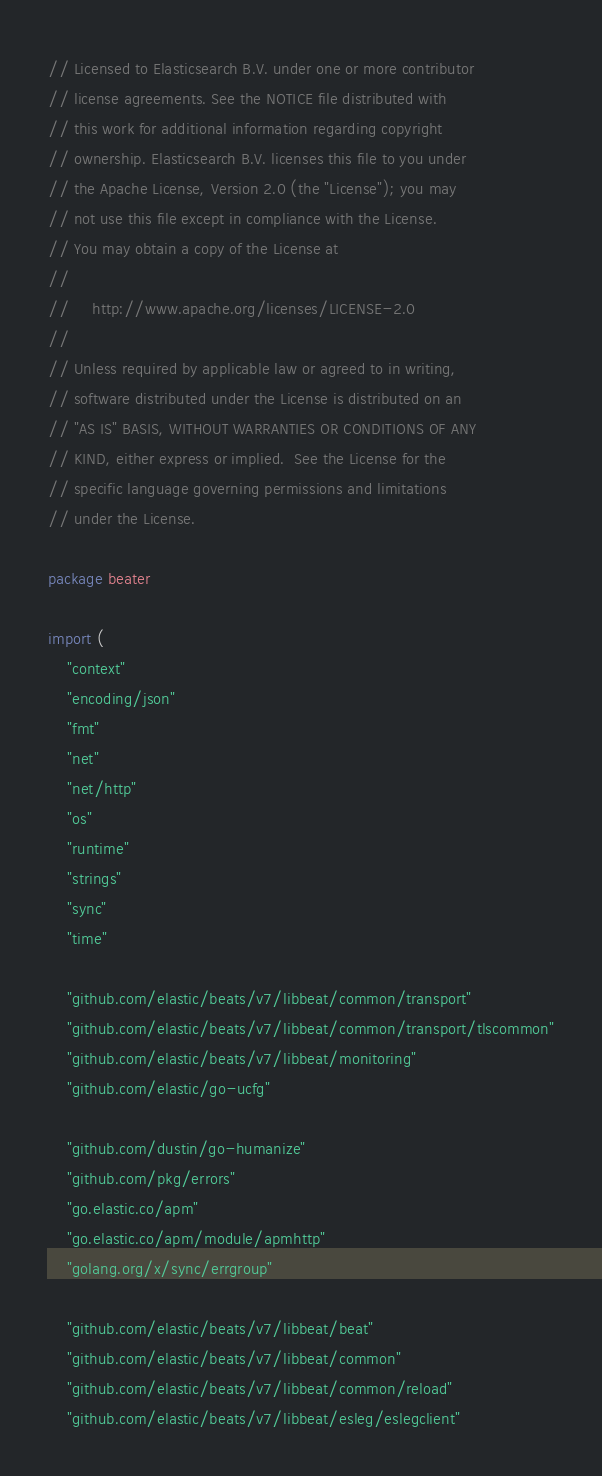Convert code to text. <code><loc_0><loc_0><loc_500><loc_500><_Go_>// Licensed to Elasticsearch B.V. under one or more contributor
// license agreements. See the NOTICE file distributed with
// this work for additional information regarding copyright
// ownership. Elasticsearch B.V. licenses this file to you under
// the Apache License, Version 2.0 (the "License"); you may
// not use this file except in compliance with the License.
// You may obtain a copy of the License at
//
//     http://www.apache.org/licenses/LICENSE-2.0
//
// Unless required by applicable law or agreed to in writing,
// software distributed under the License is distributed on an
// "AS IS" BASIS, WITHOUT WARRANTIES OR CONDITIONS OF ANY
// KIND, either express or implied.  See the License for the
// specific language governing permissions and limitations
// under the License.

package beater

import (
	"context"
	"encoding/json"
	"fmt"
	"net"
	"net/http"
	"os"
	"runtime"
	"strings"
	"sync"
	"time"

	"github.com/elastic/beats/v7/libbeat/common/transport"
	"github.com/elastic/beats/v7/libbeat/common/transport/tlscommon"
	"github.com/elastic/beats/v7/libbeat/monitoring"
	"github.com/elastic/go-ucfg"

	"github.com/dustin/go-humanize"
	"github.com/pkg/errors"
	"go.elastic.co/apm"
	"go.elastic.co/apm/module/apmhttp"
	"golang.org/x/sync/errgroup"

	"github.com/elastic/beats/v7/libbeat/beat"
	"github.com/elastic/beats/v7/libbeat/common"
	"github.com/elastic/beats/v7/libbeat/common/reload"
	"github.com/elastic/beats/v7/libbeat/esleg/eslegclient"</code> 